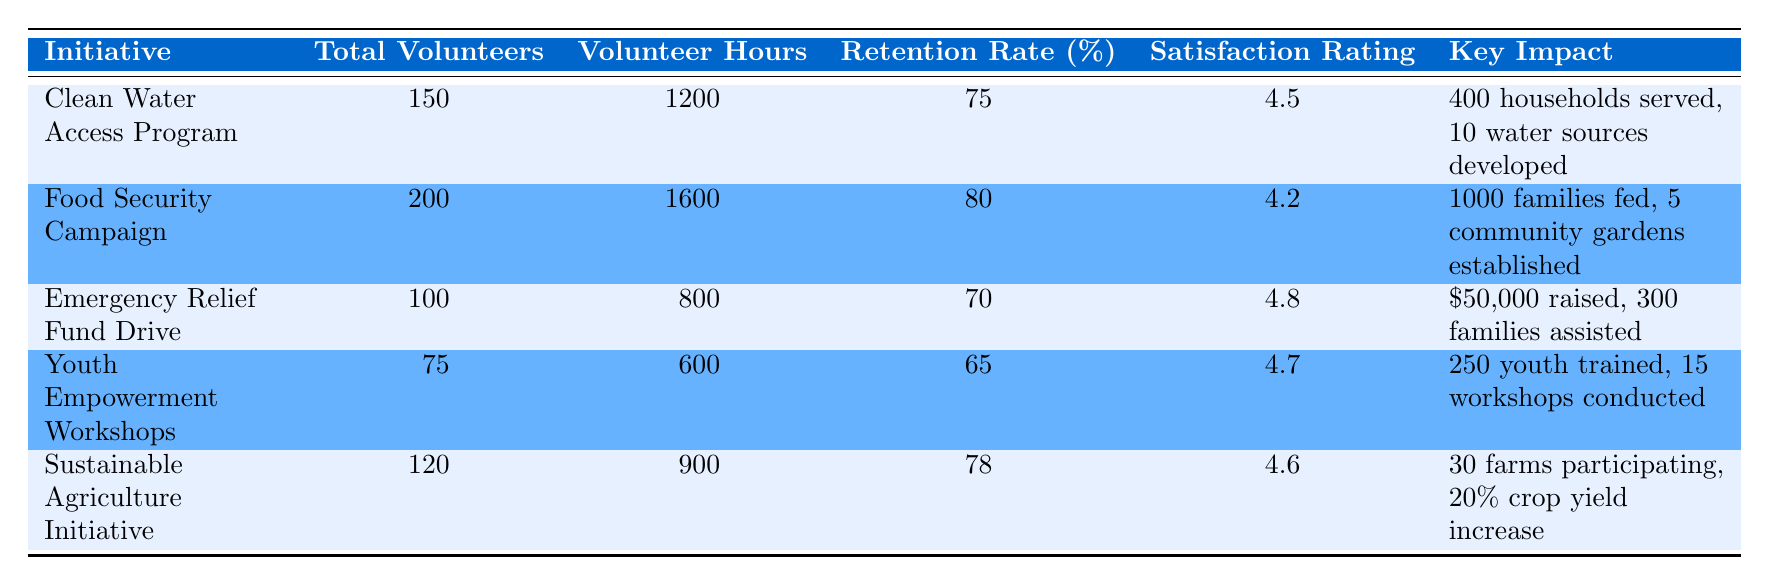What is the total number of volunteers engaged in the Food Security Campaign? The table shows that the total number of volunteers for the Food Security Campaign is explicitly listed in the "Total Volunteers" column.
Answer: 200 What is the retention rate for the Clean Water Access Program? The retention rate is provided directly in the table under the "Retention Rate (%)" column for the Clean Water Access Program.
Answer: 75 Which initiative has the highest satisfaction rating? By comparing the "Satisfaction Rating" values in the table, the Emergency Relief Fund Drive has a rating of 4.8, which is higher than the others.
Answer: Emergency Relief Fund Drive How many total volunteer hours were contributed to the Sustainable Agriculture Initiative? The table specifies the volunteer hours in the "Volunteer Hours" column for the Sustainable Agriculture Initiative, which amounts to 900 hours.
Answer: 900 What is the total number of households served by the initiatives combined? To find the total, we add the households served from the Clean Water Access Program (400) to the other initiatives. However, not all have comparable metrics for households served, making this challenging. Thus, we focus on the first initiative only explicitly mentioned.
Answer: 400 Is the total number of volunteers higher in the Youth Empowerment Workshops than in the Emergency Relief Fund Drive? The table lists 75 volunteers for the Youth Empowerment Workshops and 100 volunteers for the Emergency Relief Fund Drive, thus comparing the two reveals that the number of volunteers for the Youth Empowerment Workshops is less.
Answer: No What is the average satisfaction rating of all the initiatives listed? First, we sum up the satisfaction ratings: 4.5 + 4.2 + 4.8 + 4.7 + 4.6 = 22.8. Then, we divide that sum by the total number of initiatives, which is 5 (22.8 / 5 = 4.56).
Answer: 4.56 Which initiative had the fewest volunteers and how many were there? By scanning the "Total Volunteers" column, we see that the Youth Empowerment Workshops has the lowest number of volunteers, counting 75.
Answer: 75 What percentage increase is noted in crop yield for the Sustainable Agriculture Initiative? The table indicates a 20% increase in crop yield specifically for the Sustainable Agriculture Initiative, stated directly in the “Key Impact” column.
Answer: 20% 